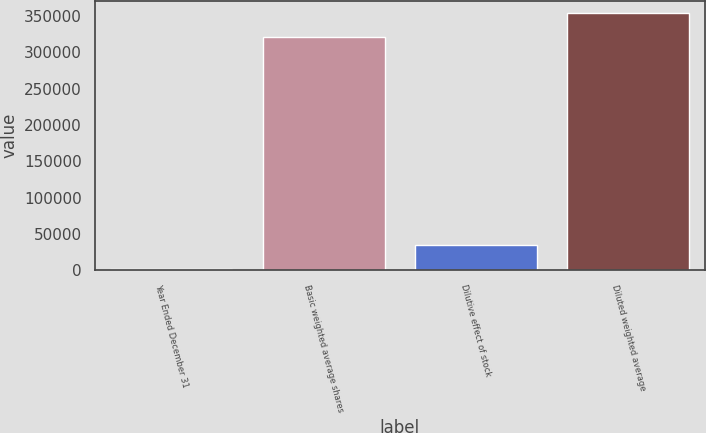Convert chart to OTSL. <chart><loc_0><loc_0><loc_500><loc_500><bar_chart><fcel>Year Ended December 31<fcel>Basic weighted average shares<fcel>Dilutive effect of stock<fcel>Diluted weighted average<nl><fcel>2015<fcel>321313<fcel>34478.7<fcel>353777<nl></chart> 